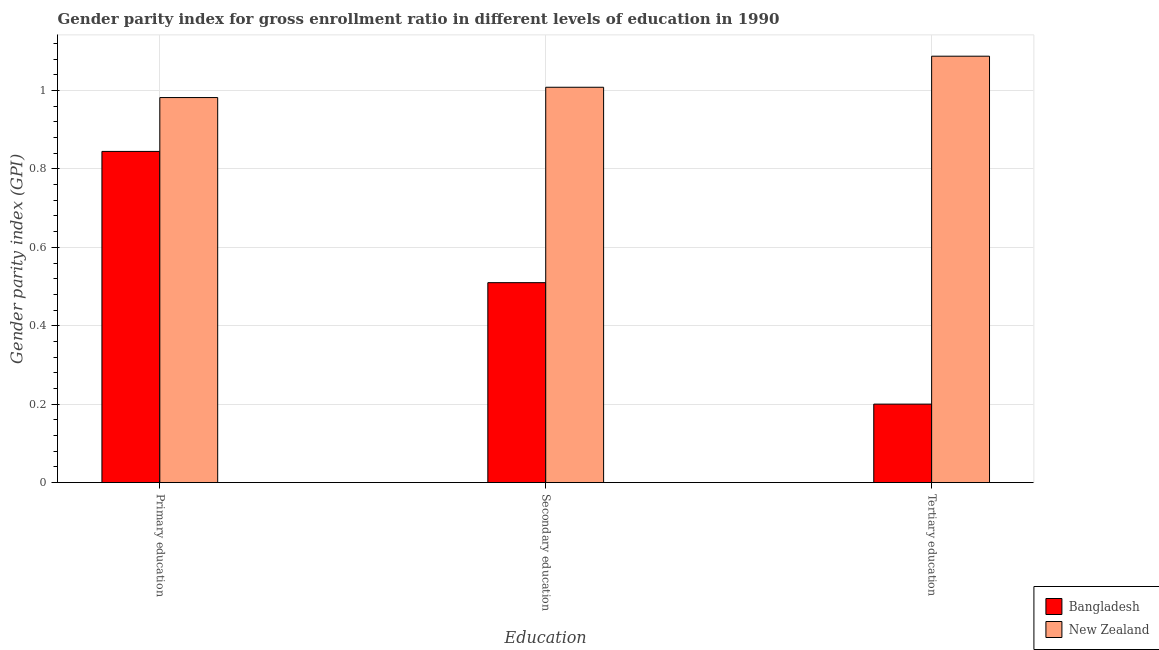How many different coloured bars are there?
Provide a short and direct response. 2. How many groups of bars are there?
Keep it short and to the point. 3. How many bars are there on the 2nd tick from the left?
Offer a terse response. 2. What is the label of the 3rd group of bars from the left?
Give a very brief answer. Tertiary education. What is the gender parity index in tertiary education in New Zealand?
Provide a succinct answer. 1.09. Across all countries, what is the maximum gender parity index in primary education?
Your response must be concise. 0.98. Across all countries, what is the minimum gender parity index in tertiary education?
Your answer should be very brief. 0.2. In which country was the gender parity index in secondary education maximum?
Your answer should be very brief. New Zealand. In which country was the gender parity index in tertiary education minimum?
Offer a very short reply. Bangladesh. What is the total gender parity index in primary education in the graph?
Your answer should be compact. 1.83. What is the difference between the gender parity index in secondary education in Bangladesh and that in New Zealand?
Make the answer very short. -0.5. What is the difference between the gender parity index in tertiary education in Bangladesh and the gender parity index in primary education in New Zealand?
Offer a terse response. -0.78. What is the average gender parity index in primary education per country?
Your answer should be very brief. 0.91. What is the difference between the gender parity index in secondary education and gender parity index in primary education in New Zealand?
Provide a short and direct response. 0.03. In how many countries, is the gender parity index in primary education greater than 0.32 ?
Provide a succinct answer. 2. What is the ratio of the gender parity index in tertiary education in Bangladesh to that in New Zealand?
Make the answer very short. 0.18. Is the difference between the gender parity index in tertiary education in New Zealand and Bangladesh greater than the difference between the gender parity index in secondary education in New Zealand and Bangladesh?
Your answer should be compact. Yes. What is the difference between the highest and the second highest gender parity index in tertiary education?
Make the answer very short. 0.89. What is the difference between the highest and the lowest gender parity index in primary education?
Provide a succinct answer. 0.14. In how many countries, is the gender parity index in tertiary education greater than the average gender parity index in tertiary education taken over all countries?
Provide a short and direct response. 1. What does the 2nd bar from the right in Tertiary education represents?
Offer a very short reply. Bangladesh. How many bars are there?
Offer a terse response. 6. Are all the bars in the graph horizontal?
Your answer should be very brief. No. What is the difference between two consecutive major ticks on the Y-axis?
Ensure brevity in your answer.  0.2. Where does the legend appear in the graph?
Provide a short and direct response. Bottom right. How many legend labels are there?
Your answer should be very brief. 2. What is the title of the graph?
Offer a terse response. Gender parity index for gross enrollment ratio in different levels of education in 1990. What is the label or title of the X-axis?
Offer a terse response. Education. What is the label or title of the Y-axis?
Provide a succinct answer. Gender parity index (GPI). What is the Gender parity index (GPI) in Bangladesh in Primary education?
Your answer should be very brief. 0.84. What is the Gender parity index (GPI) of New Zealand in Primary education?
Keep it short and to the point. 0.98. What is the Gender parity index (GPI) of Bangladesh in Secondary education?
Make the answer very short. 0.51. What is the Gender parity index (GPI) of New Zealand in Secondary education?
Provide a succinct answer. 1.01. What is the Gender parity index (GPI) in Bangladesh in Tertiary education?
Your answer should be compact. 0.2. What is the Gender parity index (GPI) in New Zealand in Tertiary education?
Your answer should be compact. 1.09. Across all Education, what is the maximum Gender parity index (GPI) in Bangladesh?
Your response must be concise. 0.84. Across all Education, what is the maximum Gender parity index (GPI) in New Zealand?
Ensure brevity in your answer.  1.09. Across all Education, what is the minimum Gender parity index (GPI) in Bangladesh?
Ensure brevity in your answer.  0.2. Across all Education, what is the minimum Gender parity index (GPI) of New Zealand?
Offer a terse response. 0.98. What is the total Gender parity index (GPI) of Bangladesh in the graph?
Make the answer very short. 1.55. What is the total Gender parity index (GPI) of New Zealand in the graph?
Your answer should be compact. 3.08. What is the difference between the Gender parity index (GPI) in Bangladesh in Primary education and that in Secondary education?
Keep it short and to the point. 0.33. What is the difference between the Gender parity index (GPI) in New Zealand in Primary education and that in Secondary education?
Keep it short and to the point. -0.03. What is the difference between the Gender parity index (GPI) of Bangladesh in Primary education and that in Tertiary education?
Your answer should be very brief. 0.64. What is the difference between the Gender parity index (GPI) of New Zealand in Primary education and that in Tertiary education?
Make the answer very short. -0.11. What is the difference between the Gender parity index (GPI) of Bangladesh in Secondary education and that in Tertiary education?
Ensure brevity in your answer.  0.31. What is the difference between the Gender parity index (GPI) of New Zealand in Secondary education and that in Tertiary education?
Give a very brief answer. -0.08. What is the difference between the Gender parity index (GPI) in Bangladesh in Primary education and the Gender parity index (GPI) in New Zealand in Secondary education?
Offer a very short reply. -0.16. What is the difference between the Gender parity index (GPI) in Bangladesh in Primary education and the Gender parity index (GPI) in New Zealand in Tertiary education?
Your answer should be very brief. -0.24. What is the difference between the Gender parity index (GPI) in Bangladesh in Secondary education and the Gender parity index (GPI) in New Zealand in Tertiary education?
Your answer should be very brief. -0.58. What is the average Gender parity index (GPI) of Bangladesh per Education?
Your answer should be very brief. 0.52. What is the average Gender parity index (GPI) of New Zealand per Education?
Make the answer very short. 1.03. What is the difference between the Gender parity index (GPI) in Bangladesh and Gender parity index (GPI) in New Zealand in Primary education?
Offer a terse response. -0.14. What is the difference between the Gender parity index (GPI) of Bangladesh and Gender parity index (GPI) of New Zealand in Secondary education?
Keep it short and to the point. -0.5. What is the difference between the Gender parity index (GPI) of Bangladesh and Gender parity index (GPI) of New Zealand in Tertiary education?
Your response must be concise. -0.89. What is the ratio of the Gender parity index (GPI) of Bangladesh in Primary education to that in Secondary education?
Your response must be concise. 1.66. What is the ratio of the Gender parity index (GPI) in New Zealand in Primary education to that in Secondary education?
Your answer should be compact. 0.97. What is the ratio of the Gender parity index (GPI) in Bangladesh in Primary education to that in Tertiary education?
Provide a short and direct response. 4.22. What is the ratio of the Gender parity index (GPI) of New Zealand in Primary education to that in Tertiary education?
Provide a short and direct response. 0.9. What is the ratio of the Gender parity index (GPI) in Bangladesh in Secondary education to that in Tertiary education?
Keep it short and to the point. 2.55. What is the ratio of the Gender parity index (GPI) in New Zealand in Secondary education to that in Tertiary education?
Offer a very short reply. 0.93. What is the difference between the highest and the second highest Gender parity index (GPI) in Bangladesh?
Ensure brevity in your answer.  0.33. What is the difference between the highest and the second highest Gender parity index (GPI) of New Zealand?
Ensure brevity in your answer.  0.08. What is the difference between the highest and the lowest Gender parity index (GPI) in Bangladesh?
Make the answer very short. 0.64. What is the difference between the highest and the lowest Gender parity index (GPI) of New Zealand?
Provide a short and direct response. 0.11. 